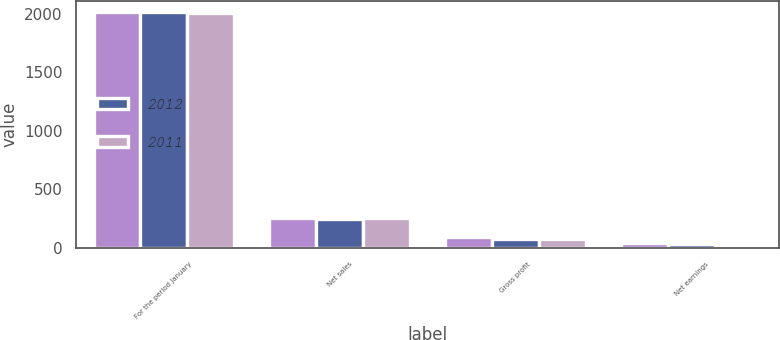Convert chart. <chart><loc_0><loc_0><loc_500><loc_500><stacked_bar_chart><ecel><fcel>For the period January<fcel>Net sales<fcel>Gross profit<fcel>Net earnings<nl><fcel>nan<fcel>2012<fcel>249<fcel>86.4<fcel>42.2<nl><fcel>2012<fcel>2011<fcel>247.4<fcel>73.1<fcel>28<nl><fcel>2011<fcel>2010<fcel>255.5<fcel>73.9<fcel>20<nl></chart> 